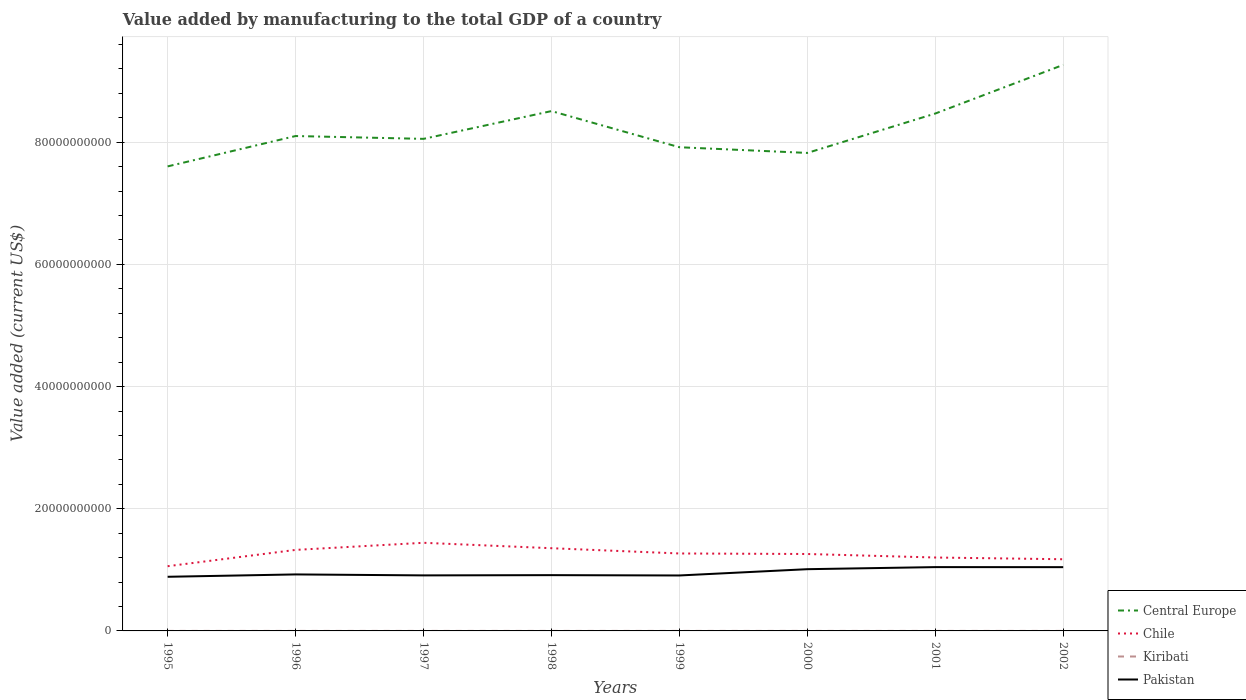Across all years, what is the maximum value added by manufacturing to the total GDP in Pakistan?
Provide a succinct answer. 8.86e+09. What is the total value added by manufacturing to the total GDP in Central Europe in the graph?
Your answer should be compact. 1.37e+09. What is the difference between the highest and the second highest value added by manufacturing to the total GDP in Kiribati?
Your answer should be compact. 7.70e+05. How many lines are there?
Offer a terse response. 4. How many years are there in the graph?
Ensure brevity in your answer.  8. What is the difference between two consecutive major ticks on the Y-axis?
Your answer should be compact. 2.00e+1. Does the graph contain any zero values?
Provide a succinct answer. No. What is the title of the graph?
Provide a succinct answer. Value added by manufacturing to the total GDP of a country. What is the label or title of the X-axis?
Keep it short and to the point. Years. What is the label or title of the Y-axis?
Ensure brevity in your answer.  Value added (current US$). What is the Value added (current US$) of Central Europe in 1995?
Offer a terse response. 7.60e+1. What is the Value added (current US$) in Chile in 1995?
Your answer should be very brief. 1.06e+1. What is the Value added (current US$) in Kiribati in 1995?
Provide a succinct answer. 3.37e+06. What is the Value added (current US$) in Pakistan in 1995?
Provide a succinct answer. 8.86e+09. What is the Value added (current US$) of Central Europe in 1996?
Keep it short and to the point. 8.10e+1. What is the Value added (current US$) in Chile in 1996?
Offer a terse response. 1.33e+1. What is the Value added (current US$) of Kiribati in 1996?
Your answer should be very brief. 3.55e+06. What is the Value added (current US$) in Pakistan in 1996?
Your answer should be very brief. 9.25e+09. What is the Value added (current US$) in Central Europe in 1997?
Ensure brevity in your answer.  8.06e+1. What is the Value added (current US$) of Chile in 1997?
Your answer should be compact. 1.44e+1. What is the Value added (current US$) in Kiribati in 1997?
Provide a short and direct response. 3.47e+06. What is the Value added (current US$) of Pakistan in 1997?
Your answer should be compact. 9.09e+09. What is the Value added (current US$) in Central Europe in 1998?
Your response must be concise. 8.51e+1. What is the Value added (current US$) in Chile in 1998?
Your answer should be compact. 1.35e+1. What is the Value added (current US$) of Kiribati in 1998?
Your answer should be very brief. 3.13e+06. What is the Value added (current US$) in Pakistan in 1998?
Offer a very short reply. 9.13e+09. What is the Value added (current US$) in Central Europe in 1999?
Provide a short and direct response. 7.92e+1. What is the Value added (current US$) in Chile in 1999?
Ensure brevity in your answer.  1.27e+1. What is the Value added (current US$) of Kiribati in 1999?
Your answer should be very brief. 3.52e+06. What is the Value added (current US$) in Pakistan in 1999?
Keep it short and to the point. 9.08e+09. What is the Value added (current US$) of Central Europe in 2000?
Offer a terse response. 7.82e+1. What is the Value added (current US$) in Chile in 2000?
Make the answer very short. 1.26e+1. What is the Value added (current US$) in Kiribati in 2000?
Provide a succinct answer. 2.98e+06. What is the Value added (current US$) of Pakistan in 2000?
Provide a succinct answer. 1.01e+1. What is the Value added (current US$) of Central Europe in 2001?
Offer a terse response. 8.47e+1. What is the Value added (current US$) of Chile in 2001?
Provide a short and direct response. 1.20e+1. What is the Value added (current US$) in Kiribati in 2001?
Your response must be concise. 2.78e+06. What is the Value added (current US$) of Pakistan in 2001?
Provide a succinct answer. 1.04e+1. What is the Value added (current US$) of Central Europe in 2002?
Offer a terse response. 9.27e+1. What is the Value added (current US$) of Chile in 2002?
Provide a succinct answer. 1.17e+1. What is the Value added (current US$) of Kiribati in 2002?
Offer a very short reply. 2.85e+06. What is the Value added (current US$) of Pakistan in 2002?
Offer a very short reply. 1.04e+1. Across all years, what is the maximum Value added (current US$) of Central Europe?
Offer a very short reply. 9.27e+1. Across all years, what is the maximum Value added (current US$) in Chile?
Your response must be concise. 1.44e+1. Across all years, what is the maximum Value added (current US$) of Kiribati?
Provide a succinct answer. 3.55e+06. Across all years, what is the maximum Value added (current US$) in Pakistan?
Keep it short and to the point. 1.04e+1. Across all years, what is the minimum Value added (current US$) of Central Europe?
Provide a short and direct response. 7.60e+1. Across all years, what is the minimum Value added (current US$) of Chile?
Ensure brevity in your answer.  1.06e+1. Across all years, what is the minimum Value added (current US$) in Kiribati?
Your response must be concise. 2.78e+06. Across all years, what is the minimum Value added (current US$) in Pakistan?
Provide a short and direct response. 8.86e+09. What is the total Value added (current US$) in Central Europe in the graph?
Ensure brevity in your answer.  6.57e+11. What is the total Value added (current US$) of Chile in the graph?
Make the answer very short. 1.01e+11. What is the total Value added (current US$) of Kiribati in the graph?
Ensure brevity in your answer.  2.57e+07. What is the total Value added (current US$) of Pakistan in the graph?
Give a very brief answer. 7.64e+1. What is the difference between the Value added (current US$) of Central Europe in 1995 and that in 1996?
Ensure brevity in your answer.  -4.97e+09. What is the difference between the Value added (current US$) in Chile in 1995 and that in 1996?
Offer a very short reply. -2.67e+09. What is the difference between the Value added (current US$) of Kiribati in 1995 and that in 1996?
Provide a succinct answer. -1.88e+05. What is the difference between the Value added (current US$) of Pakistan in 1995 and that in 1996?
Your answer should be compact. -3.86e+08. What is the difference between the Value added (current US$) of Central Europe in 1995 and that in 1997?
Keep it short and to the point. -4.51e+09. What is the difference between the Value added (current US$) in Chile in 1995 and that in 1997?
Provide a short and direct response. -3.83e+09. What is the difference between the Value added (current US$) in Kiribati in 1995 and that in 1997?
Provide a succinct answer. -1.05e+05. What is the difference between the Value added (current US$) of Pakistan in 1995 and that in 1997?
Your response must be concise. -2.27e+08. What is the difference between the Value added (current US$) of Central Europe in 1995 and that in 1998?
Provide a short and direct response. -9.05e+09. What is the difference between the Value added (current US$) of Chile in 1995 and that in 1998?
Your response must be concise. -2.95e+09. What is the difference between the Value added (current US$) of Kiribati in 1995 and that in 1998?
Ensure brevity in your answer.  2.32e+05. What is the difference between the Value added (current US$) in Pakistan in 1995 and that in 1998?
Offer a terse response. -2.68e+08. What is the difference between the Value added (current US$) in Central Europe in 1995 and that in 1999?
Make the answer very short. -3.14e+09. What is the difference between the Value added (current US$) of Chile in 1995 and that in 1999?
Make the answer very short. -2.08e+09. What is the difference between the Value added (current US$) of Kiribati in 1995 and that in 1999?
Your response must be concise. -1.54e+05. What is the difference between the Value added (current US$) in Pakistan in 1995 and that in 1999?
Make the answer very short. -2.13e+08. What is the difference between the Value added (current US$) of Central Europe in 1995 and that in 2000?
Your answer should be very brief. -2.21e+09. What is the difference between the Value added (current US$) of Chile in 1995 and that in 2000?
Keep it short and to the point. -2.00e+09. What is the difference between the Value added (current US$) in Kiribati in 1995 and that in 2000?
Make the answer very short. 3.87e+05. What is the difference between the Value added (current US$) in Pakistan in 1995 and that in 2000?
Give a very brief answer. -1.24e+09. What is the difference between the Value added (current US$) of Central Europe in 1995 and that in 2001?
Keep it short and to the point. -8.65e+09. What is the difference between the Value added (current US$) of Chile in 1995 and that in 2001?
Make the answer very short. -1.42e+09. What is the difference between the Value added (current US$) of Kiribati in 1995 and that in 2001?
Your response must be concise. 5.82e+05. What is the difference between the Value added (current US$) in Pakistan in 1995 and that in 2001?
Provide a short and direct response. -1.58e+09. What is the difference between the Value added (current US$) in Central Europe in 1995 and that in 2002?
Your response must be concise. -1.66e+1. What is the difference between the Value added (current US$) of Chile in 1995 and that in 2002?
Offer a terse response. -1.14e+09. What is the difference between the Value added (current US$) in Kiribati in 1995 and that in 2002?
Give a very brief answer. 5.20e+05. What is the difference between the Value added (current US$) of Pakistan in 1995 and that in 2002?
Your answer should be very brief. -1.58e+09. What is the difference between the Value added (current US$) of Central Europe in 1996 and that in 1997?
Your response must be concise. 4.64e+08. What is the difference between the Value added (current US$) in Chile in 1996 and that in 1997?
Your answer should be very brief. -1.16e+09. What is the difference between the Value added (current US$) in Kiribati in 1996 and that in 1997?
Ensure brevity in your answer.  8.27e+04. What is the difference between the Value added (current US$) in Pakistan in 1996 and that in 1997?
Offer a terse response. 1.59e+08. What is the difference between the Value added (current US$) in Central Europe in 1996 and that in 1998?
Your answer should be compact. -4.08e+09. What is the difference between the Value added (current US$) in Chile in 1996 and that in 1998?
Provide a short and direct response. -2.76e+08. What is the difference between the Value added (current US$) in Kiribati in 1996 and that in 1998?
Your answer should be compact. 4.20e+05. What is the difference between the Value added (current US$) of Pakistan in 1996 and that in 1998?
Your answer should be very brief. 1.18e+08. What is the difference between the Value added (current US$) of Central Europe in 1996 and that in 1999?
Provide a succinct answer. 1.83e+09. What is the difference between the Value added (current US$) of Chile in 1996 and that in 1999?
Keep it short and to the point. 5.85e+08. What is the difference between the Value added (current US$) of Kiribati in 1996 and that in 1999?
Offer a very short reply. 3.37e+04. What is the difference between the Value added (current US$) of Pakistan in 1996 and that in 1999?
Give a very brief answer. 1.73e+08. What is the difference between the Value added (current US$) of Central Europe in 1996 and that in 2000?
Provide a short and direct response. 2.77e+09. What is the difference between the Value added (current US$) in Chile in 1996 and that in 2000?
Keep it short and to the point. 6.71e+08. What is the difference between the Value added (current US$) in Kiribati in 1996 and that in 2000?
Ensure brevity in your answer.  5.76e+05. What is the difference between the Value added (current US$) of Pakistan in 1996 and that in 2000?
Offer a terse response. -8.55e+08. What is the difference between the Value added (current US$) in Central Europe in 1996 and that in 2001?
Provide a succinct answer. -3.68e+09. What is the difference between the Value added (current US$) in Chile in 1996 and that in 2001?
Give a very brief answer. 1.25e+09. What is the difference between the Value added (current US$) of Kiribati in 1996 and that in 2001?
Provide a short and direct response. 7.70e+05. What is the difference between the Value added (current US$) in Pakistan in 1996 and that in 2001?
Your answer should be compact. -1.20e+09. What is the difference between the Value added (current US$) of Central Europe in 1996 and that in 2002?
Your answer should be very brief. -1.16e+1. What is the difference between the Value added (current US$) in Chile in 1996 and that in 2002?
Your answer should be very brief. 1.53e+09. What is the difference between the Value added (current US$) of Kiribati in 1996 and that in 2002?
Offer a terse response. 7.08e+05. What is the difference between the Value added (current US$) of Pakistan in 1996 and that in 2002?
Make the answer very short. -1.19e+09. What is the difference between the Value added (current US$) in Central Europe in 1997 and that in 1998?
Provide a succinct answer. -4.55e+09. What is the difference between the Value added (current US$) of Chile in 1997 and that in 1998?
Your answer should be very brief. 8.87e+08. What is the difference between the Value added (current US$) of Kiribati in 1997 and that in 1998?
Offer a very short reply. 3.37e+05. What is the difference between the Value added (current US$) of Pakistan in 1997 and that in 1998?
Keep it short and to the point. -4.09e+07. What is the difference between the Value added (current US$) in Central Europe in 1997 and that in 1999?
Offer a terse response. 1.37e+09. What is the difference between the Value added (current US$) in Chile in 1997 and that in 1999?
Offer a terse response. 1.75e+09. What is the difference between the Value added (current US$) of Kiribati in 1997 and that in 1999?
Your answer should be very brief. -4.90e+04. What is the difference between the Value added (current US$) of Pakistan in 1997 and that in 1999?
Provide a succinct answer. 1.38e+07. What is the difference between the Value added (current US$) of Central Europe in 1997 and that in 2000?
Give a very brief answer. 2.30e+09. What is the difference between the Value added (current US$) in Chile in 1997 and that in 2000?
Give a very brief answer. 1.83e+09. What is the difference between the Value added (current US$) in Kiribati in 1997 and that in 2000?
Give a very brief answer. 4.93e+05. What is the difference between the Value added (current US$) of Pakistan in 1997 and that in 2000?
Offer a very short reply. -1.01e+09. What is the difference between the Value added (current US$) in Central Europe in 1997 and that in 2001?
Make the answer very short. -4.15e+09. What is the difference between the Value added (current US$) in Chile in 1997 and that in 2001?
Offer a terse response. 2.41e+09. What is the difference between the Value added (current US$) of Kiribati in 1997 and that in 2001?
Make the answer very short. 6.88e+05. What is the difference between the Value added (current US$) of Pakistan in 1997 and that in 2001?
Ensure brevity in your answer.  -1.35e+09. What is the difference between the Value added (current US$) in Central Europe in 1997 and that in 2002?
Provide a short and direct response. -1.21e+1. What is the difference between the Value added (current US$) of Chile in 1997 and that in 2002?
Provide a short and direct response. 2.69e+09. What is the difference between the Value added (current US$) of Kiribati in 1997 and that in 2002?
Offer a terse response. 6.25e+05. What is the difference between the Value added (current US$) of Pakistan in 1997 and that in 2002?
Ensure brevity in your answer.  -1.35e+09. What is the difference between the Value added (current US$) of Central Europe in 1998 and that in 1999?
Make the answer very short. 5.92e+09. What is the difference between the Value added (current US$) of Chile in 1998 and that in 1999?
Your answer should be very brief. 8.62e+08. What is the difference between the Value added (current US$) in Kiribati in 1998 and that in 1999?
Offer a very short reply. -3.86e+05. What is the difference between the Value added (current US$) of Pakistan in 1998 and that in 1999?
Ensure brevity in your answer.  5.46e+07. What is the difference between the Value added (current US$) in Central Europe in 1998 and that in 2000?
Make the answer very short. 6.85e+09. What is the difference between the Value added (current US$) in Chile in 1998 and that in 2000?
Offer a terse response. 9.47e+08. What is the difference between the Value added (current US$) in Kiribati in 1998 and that in 2000?
Offer a very short reply. 1.56e+05. What is the difference between the Value added (current US$) in Pakistan in 1998 and that in 2000?
Provide a succinct answer. -9.73e+08. What is the difference between the Value added (current US$) in Central Europe in 1998 and that in 2001?
Your response must be concise. 4.01e+08. What is the difference between the Value added (current US$) of Chile in 1998 and that in 2001?
Your answer should be very brief. 1.52e+09. What is the difference between the Value added (current US$) in Kiribati in 1998 and that in 2001?
Keep it short and to the point. 3.51e+05. What is the difference between the Value added (current US$) in Pakistan in 1998 and that in 2001?
Offer a terse response. -1.31e+09. What is the difference between the Value added (current US$) in Central Europe in 1998 and that in 2002?
Your answer should be very brief. -7.56e+09. What is the difference between the Value added (current US$) of Chile in 1998 and that in 2002?
Keep it short and to the point. 1.81e+09. What is the difference between the Value added (current US$) of Kiribati in 1998 and that in 2002?
Provide a short and direct response. 2.88e+05. What is the difference between the Value added (current US$) of Pakistan in 1998 and that in 2002?
Offer a very short reply. -1.31e+09. What is the difference between the Value added (current US$) of Central Europe in 1999 and that in 2000?
Make the answer very short. 9.32e+08. What is the difference between the Value added (current US$) in Chile in 1999 and that in 2000?
Ensure brevity in your answer.  8.55e+07. What is the difference between the Value added (current US$) of Kiribati in 1999 and that in 2000?
Offer a terse response. 5.42e+05. What is the difference between the Value added (current US$) of Pakistan in 1999 and that in 2000?
Make the answer very short. -1.03e+09. What is the difference between the Value added (current US$) of Central Europe in 1999 and that in 2001?
Keep it short and to the point. -5.52e+09. What is the difference between the Value added (current US$) of Chile in 1999 and that in 2001?
Provide a short and direct response. 6.61e+08. What is the difference between the Value added (current US$) of Kiribati in 1999 and that in 2001?
Your response must be concise. 7.37e+05. What is the difference between the Value added (current US$) in Pakistan in 1999 and that in 2001?
Offer a very short reply. -1.37e+09. What is the difference between the Value added (current US$) of Central Europe in 1999 and that in 2002?
Your response must be concise. -1.35e+1. What is the difference between the Value added (current US$) of Chile in 1999 and that in 2002?
Give a very brief answer. 9.45e+08. What is the difference between the Value added (current US$) in Kiribati in 1999 and that in 2002?
Keep it short and to the point. 6.74e+05. What is the difference between the Value added (current US$) in Pakistan in 1999 and that in 2002?
Make the answer very short. -1.36e+09. What is the difference between the Value added (current US$) of Central Europe in 2000 and that in 2001?
Provide a succinct answer. -6.45e+09. What is the difference between the Value added (current US$) of Chile in 2000 and that in 2001?
Your answer should be compact. 5.75e+08. What is the difference between the Value added (current US$) in Kiribati in 2000 and that in 2001?
Provide a succinct answer. 1.95e+05. What is the difference between the Value added (current US$) in Pakistan in 2000 and that in 2001?
Keep it short and to the point. -3.41e+08. What is the difference between the Value added (current US$) of Central Europe in 2000 and that in 2002?
Your answer should be very brief. -1.44e+1. What is the difference between the Value added (current US$) in Chile in 2000 and that in 2002?
Offer a very short reply. 8.59e+08. What is the difference between the Value added (current US$) in Kiribati in 2000 and that in 2002?
Ensure brevity in your answer.  1.32e+05. What is the difference between the Value added (current US$) in Pakistan in 2000 and that in 2002?
Make the answer very short. -3.34e+08. What is the difference between the Value added (current US$) in Central Europe in 2001 and that in 2002?
Provide a succinct answer. -7.97e+09. What is the difference between the Value added (current US$) in Chile in 2001 and that in 2002?
Your answer should be very brief. 2.84e+08. What is the difference between the Value added (current US$) in Kiribati in 2001 and that in 2002?
Provide a short and direct response. -6.24e+04. What is the difference between the Value added (current US$) in Pakistan in 2001 and that in 2002?
Ensure brevity in your answer.  6.15e+06. What is the difference between the Value added (current US$) of Central Europe in 1995 and the Value added (current US$) of Chile in 1996?
Provide a succinct answer. 6.28e+1. What is the difference between the Value added (current US$) in Central Europe in 1995 and the Value added (current US$) in Kiribati in 1996?
Your answer should be compact. 7.60e+1. What is the difference between the Value added (current US$) in Central Europe in 1995 and the Value added (current US$) in Pakistan in 1996?
Ensure brevity in your answer.  6.68e+1. What is the difference between the Value added (current US$) of Chile in 1995 and the Value added (current US$) of Kiribati in 1996?
Give a very brief answer. 1.06e+1. What is the difference between the Value added (current US$) in Chile in 1995 and the Value added (current US$) in Pakistan in 1996?
Provide a short and direct response. 1.34e+09. What is the difference between the Value added (current US$) in Kiribati in 1995 and the Value added (current US$) in Pakistan in 1996?
Offer a terse response. -9.25e+09. What is the difference between the Value added (current US$) in Central Europe in 1995 and the Value added (current US$) in Chile in 1997?
Provide a succinct answer. 6.16e+1. What is the difference between the Value added (current US$) of Central Europe in 1995 and the Value added (current US$) of Kiribati in 1997?
Make the answer very short. 7.60e+1. What is the difference between the Value added (current US$) in Central Europe in 1995 and the Value added (current US$) in Pakistan in 1997?
Offer a terse response. 6.70e+1. What is the difference between the Value added (current US$) of Chile in 1995 and the Value added (current US$) of Kiribati in 1997?
Provide a succinct answer. 1.06e+1. What is the difference between the Value added (current US$) of Chile in 1995 and the Value added (current US$) of Pakistan in 1997?
Give a very brief answer. 1.50e+09. What is the difference between the Value added (current US$) in Kiribati in 1995 and the Value added (current US$) in Pakistan in 1997?
Your response must be concise. -9.09e+09. What is the difference between the Value added (current US$) in Central Europe in 1995 and the Value added (current US$) in Chile in 1998?
Your answer should be compact. 6.25e+1. What is the difference between the Value added (current US$) in Central Europe in 1995 and the Value added (current US$) in Kiribati in 1998?
Your answer should be very brief. 7.60e+1. What is the difference between the Value added (current US$) in Central Europe in 1995 and the Value added (current US$) in Pakistan in 1998?
Make the answer very short. 6.69e+1. What is the difference between the Value added (current US$) of Chile in 1995 and the Value added (current US$) of Kiribati in 1998?
Give a very brief answer. 1.06e+1. What is the difference between the Value added (current US$) of Chile in 1995 and the Value added (current US$) of Pakistan in 1998?
Ensure brevity in your answer.  1.46e+09. What is the difference between the Value added (current US$) of Kiribati in 1995 and the Value added (current US$) of Pakistan in 1998?
Keep it short and to the point. -9.13e+09. What is the difference between the Value added (current US$) in Central Europe in 1995 and the Value added (current US$) in Chile in 1999?
Provide a succinct answer. 6.34e+1. What is the difference between the Value added (current US$) in Central Europe in 1995 and the Value added (current US$) in Kiribati in 1999?
Make the answer very short. 7.60e+1. What is the difference between the Value added (current US$) in Central Europe in 1995 and the Value added (current US$) in Pakistan in 1999?
Make the answer very short. 6.70e+1. What is the difference between the Value added (current US$) in Chile in 1995 and the Value added (current US$) in Kiribati in 1999?
Give a very brief answer. 1.06e+1. What is the difference between the Value added (current US$) of Chile in 1995 and the Value added (current US$) of Pakistan in 1999?
Make the answer very short. 1.52e+09. What is the difference between the Value added (current US$) in Kiribati in 1995 and the Value added (current US$) in Pakistan in 1999?
Offer a terse response. -9.07e+09. What is the difference between the Value added (current US$) of Central Europe in 1995 and the Value added (current US$) of Chile in 2000?
Offer a terse response. 6.35e+1. What is the difference between the Value added (current US$) of Central Europe in 1995 and the Value added (current US$) of Kiribati in 2000?
Ensure brevity in your answer.  7.60e+1. What is the difference between the Value added (current US$) in Central Europe in 1995 and the Value added (current US$) in Pakistan in 2000?
Your answer should be compact. 6.59e+1. What is the difference between the Value added (current US$) of Chile in 1995 and the Value added (current US$) of Kiribati in 2000?
Your answer should be very brief. 1.06e+1. What is the difference between the Value added (current US$) of Chile in 1995 and the Value added (current US$) of Pakistan in 2000?
Keep it short and to the point. 4.89e+08. What is the difference between the Value added (current US$) of Kiribati in 1995 and the Value added (current US$) of Pakistan in 2000?
Provide a short and direct response. -1.01e+1. What is the difference between the Value added (current US$) of Central Europe in 1995 and the Value added (current US$) of Chile in 2001?
Give a very brief answer. 6.40e+1. What is the difference between the Value added (current US$) in Central Europe in 1995 and the Value added (current US$) in Kiribati in 2001?
Your response must be concise. 7.60e+1. What is the difference between the Value added (current US$) in Central Europe in 1995 and the Value added (current US$) in Pakistan in 2001?
Make the answer very short. 6.56e+1. What is the difference between the Value added (current US$) in Chile in 1995 and the Value added (current US$) in Kiribati in 2001?
Provide a succinct answer. 1.06e+1. What is the difference between the Value added (current US$) of Chile in 1995 and the Value added (current US$) of Pakistan in 2001?
Provide a short and direct response. 1.48e+08. What is the difference between the Value added (current US$) of Kiribati in 1995 and the Value added (current US$) of Pakistan in 2001?
Provide a short and direct response. -1.04e+1. What is the difference between the Value added (current US$) of Central Europe in 1995 and the Value added (current US$) of Chile in 2002?
Provide a succinct answer. 6.43e+1. What is the difference between the Value added (current US$) of Central Europe in 1995 and the Value added (current US$) of Kiribati in 2002?
Offer a terse response. 7.60e+1. What is the difference between the Value added (current US$) of Central Europe in 1995 and the Value added (current US$) of Pakistan in 2002?
Give a very brief answer. 6.56e+1. What is the difference between the Value added (current US$) in Chile in 1995 and the Value added (current US$) in Kiribati in 2002?
Ensure brevity in your answer.  1.06e+1. What is the difference between the Value added (current US$) of Chile in 1995 and the Value added (current US$) of Pakistan in 2002?
Provide a succinct answer. 1.54e+08. What is the difference between the Value added (current US$) in Kiribati in 1995 and the Value added (current US$) in Pakistan in 2002?
Ensure brevity in your answer.  -1.04e+1. What is the difference between the Value added (current US$) in Central Europe in 1996 and the Value added (current US$) in Chile in 1997?
Keep it short and to the point. 6.66e+1. What is the difference between the Value added (current US$) of Central Europe in 1996 and the Value added (current US$) of Kiribati in 1997?
Offer a very short reply. 8.10e+1. What is the difference between the Value added (current US$) of Central Europe in 1996 and the Value added (current US$) of Pakistan in 1997?
Offer a very short reply. 7.19e+1. What is the difference between the Value added (current US$) in Chile in 1996 and the Value added (current US$) in Kiribati in 1997?
Provide a succinct answer. 1.33e+1. What is the difference between the Value added (current US$) in Chile in 1996 and the Value added (current US$) in Pakistan in 1997?
Your response must be concise. 4.17e+09. What is the difference between the Value added (current US$) of Kiribati in 1996 and the Value added (current US$) of Pakistan in 1997?
Your answer should be very brief. -9.09e+09. What is the difference between the Value added (current US$) of Central Europe in 1996 and the Value added (current US$) of Chile in 1998?
Your answer should be compact. 6.75e+1. What is the difference between the Value added (current US$) in Central Europe in 1996 and the Value added (current US$) in Kiribati in 1998?
Keep it short and to the point. 8.10e+1. What is the difference between the Value added (current US$) in Central Europe in 1996 and the Value added (current US$) in Pakistan in 1998?
Give a very brief answer. 7.19e+1. What is the difference between the Value added (current US$) of Chile in 1996 and the Value added (current US$) of Kiribati in 1998?
Keep it short and to the point. 1.33e+1. What is the difference between the Value added (current US$) of Chile in 1996 and the Value added (current US$) of Pakistan in 1998?
Your answer should be compact. 4.13e+09. What is the difference between the Value added (current US$) in Kiribati in 1996 and the Value added (current US$) in Pakistan in 1998?
Provide a short and direct response. -9.13e+09. What is the difference between the Value added (current US$) of Central Europe in 1996 and the Value added (current US$) of Chile in 1999?
Offer a very short reply. 6.83e+1. What is the difference between the Value added (current US$) of Central Europe in 1996 and the Value added (current US$) of Kiribati in 1999?
Offer a very short reply. 8.10e+1. What is the difference between the Value added (current US$) of Central Europe in 1996 and the Value added (current US$) of Pakistan in 1999?
Make the answer very short. 7.19e+1. What is the difference between the Value added (current US$) in Chile in 1996 and the Value added (current US$) in Kiribati in 1999?
Offer a terse response. 1.33e+1. What is the difference between the Value added (current US$) in Chile in 1996 and the Value added (current US$) in Pakistan in 1999?
Offer a very short reply. 4.19e+09. What is the difference between the Value added (current US$) in Kiribati in 1996 and the Value added (current US$) in Pakistan in 1999?
Keep it short and to the point. -9.07e+09. What is the difference between the Value added (current US$) in Central Europe in 1996 and the Value added (current US$) in Chile in 2000?
Your response must be concise. 6.84e+1. What is the difference between the Value added (current US$) of Central Europe in 1996 and the Value added (current US$) of Kiribati in 2000?
Make the answer very short. 8.10e+1. What is the difference between the Value added (current US$) of Central Europe in 1996 and the Value added (current US$) of Pakistan in 2000?
Ensure brevity in your answer.  7.09e+1. What is the difference between the Value added (current US$) of Chile in 1996 and the Value added (current US$) of Kiribati in 2000?
Offer a terse response. 1.33e+1. What is the difference between the Value added (current US$) in Chile in 1996 and the Value added (current US$) in Pakistan in 2000?
Your response must be concise. 3.16e+09. What is the difference between the Value added (current US$) of Kiribati in 1996 and the Value added (current US$) of Pakistan in 2000?
Offer a terse response. -1.01e+1. What is the difference between the Value added (current US$) of Central Europe in 1996 and the Value added (current US$) of Chile in 2001?
Make the answer very short. 6.90e+1. What is the difference between the Value added (current US$) of Central Europe in 1996 and the Value added (current US$) of Kiribati in 2001?
Your response must be concise. 8.10e+1. What is the difference between the Value added (current US$) of Central Europe in 1996 and the Value added (current US$) of Pakistan in 2001?
Give a very brief answer. 7.06e+1. What is the difference between the Value added (current US$) in Chile in 1996 and the Value added (current US$) in Kiribati in 2001?
Ensure brevity in your answer.  1.33e+1. What is the difference between the Value added (current US$) in Chile in 1996 and the Value added (current US$) in Pakistan in 2001?
Provide a short and direct response. 2.82e+09. What is the difference between the Value added (current US$) in Kiribati in 1996 and the Value added (current US$) in Pakistan in 2001?
Make the answer very short. -1.04e+1. What is the difference between the Value added (current US$) in Central Europe in 1996 and the Value added (current US$) in Chile in 2002?
Make the answer very short. 6.93e+1. What is the difference between the Value added (current US$) in Central Europe in 1996 and the Value added (current US$) in Kiribati in 2002?
Your answer should be compact. 8.10e+1. What is the difference between the Value added (current US$) in Central Europe in 1996 and the Value added (current US$) in Pakistan in 2002?
Offer a very short reply. 7.06e+1. What is the difference between the Value added (current US$) in Chile in 1996 and the Value added (current US$) in Kiribati in 2002?
Make the answer very short. 1.33e+1. What is the difference between the Value added (current US$) in Chile in 1996 and the Value added (current US$) in Pakistan in 2002?
Give a very brief answer. 2.82e+09. What is the difference between the Value added (current US$) of Kiribati in 1996 and the Value added (current US$) of Pakistan in 2002?
Provide a short and direct response. -1.04e+1. What is the difference between the Value added (current US$) in Central Europe in 1997 and the Value added (current US$) in Chile in 1998?
Make the answer very short. 6.70e+1. What is the difference between the Value added (current US$) in Central Europe in 1997 and the Value added (current US$) in Kiribati in 1998?
Your response must be concise. 8.05e+1. What is the difference between the Value added (current US$) in Central Europe in 1997 and the Value added (current US$) in Pakistan in 1998?
Provide a short and direct response. 7.14e+1. What is the difference between the Value added (current US$) of Chile in 1997 and the Value added (current US$) of Kiribati in 1998?
Provide a succinct answer. 1.44e+1. What is the difference between the Value added (current US$) in Chile in 1997 and the Value added (current US$) in Pakistan in 1998?
Your response must be concise. 5.30e+09. What is the difference between the Value added (current US$) in Kiribati in 1997 and the Value added (current US$) in Pakistan in 1998?
Your response must be concise. -9.13e+09. What is the difference between the Value added (current US$) in Central Europe in 1997 and the Value added (current US$) in Chile in 1999?
Provide a succinct answer. 6.79e+1. What is the difference between the Value added (current US$) of Central Europe in 1997 and the Value added (current US$) of Kiribati in 1999?
Ensure brevity in your answer.  8.05e+1. What is the difference between the Value added (current US$) of Central Europe in 1997 and the Value added (current US$) of Pakistan in 1999?
Ensure brevity in your answer.  7.15e+1. What is the difference between the Value added (current US$) of Chile in 1997 and the Value added (current US$) of Kiribati in 1999?
Your answer should be very brief. 1.44e+1. What is the difference between the Value added (current US$) of Chile in 1997 and the Value added (current US$) of Pakistan in 1999?
Provide a short and direct response. 5.35e+09. What is the difference between the Value added (current US$) in Kiribati in 1997 and the Value added (current US$) in Pakistan in 1999?
Offer a terse response. -9.07e+09. What is the difference between the Value added (current US$) of Central Europe in 1997 and the Value added (current US$) of Chile in 2000?
Keep it short and to the point. 6.80e+1. What is the difference between the Value added (current US$) in Central Europe in 1997 and the Value added (current US$) in Kiribati in 2000?
Your answer should be very brief. 8.05e+1. What is the difference between the Value added (current US$) of Central Europe in 1997 and the Value added (current US$) of Pakistan in 2000?
Give a very brief answer. 7.04e+1. What is the difference between the Value added (current US$) in Chile in 1997 and the Value added (current US$) in Kiribati in 2000?
Provide a succinct answer. 1.44e+1. What is the difference between the Value added (current US$) of Chile in 1997 and the Value added (current US$) of Pakistan in 2000?
Ensure brevity in your answer.  4.32e+09. What is the difference between the Value added (current US$) in Kiribati in 1997 and the Value added (current US$) in Pakistan in 2000?
Make the answer very short. -1.01e+1. What is the difference between the Value added (current US$) of Central Europe in 1997 and the Value added (current US$) of Chile in 2001?
Make the answer very short. 6.85e+1. What is the difference between the Value added (current US$) of Central Europe in 1997 and the Value added (current US$) of Kiribati in 2001?
Your response must be concise. 8.05e+1. What is the difference between the Value added (current US$) in Central Europe in 1997 and the Value added (current US$) in Pakistan in 2001?
Keep it short and to the point. 7.01e+1. What is the difference between the Value added (current US$) of Chile in 1997 and the Value added (current US$) of Kiribati in 2001?
Offer a very short reply. 1.44e+1. What is the difference between the Value added (current US$) in Chile in 1997 and the Value added (current US$) in Pakistan in 2001?
Give a very brief answer. 3.98e+09. What is the difference between the Value added (current US$) of Kiribati in 1997 and the Value added (current US$) of Pakistan in 2001?
Your answer should be compact. -1.04e+1. What is the difference between the Value added (current US$) in Central Europe in 1997 and the Value added (current US$) in Chile in 2002?
Ensure brevity in your answer.  6.88e+1. What is the difference between the Value added (current US$) in Central Europe in 1997 and the Value added (current US$) in Kiribati in 2002?
Your answer should be very brief. 8.05e+1. What is the difference between the Value added (current US$) in Central Europe in 1997 and the Value added (current US$) in Pakistan in 2002?
Ensure brevity in your answer.  7.01e+1. What is the difference between the Value added (current US$) of Chile in 1997 and the Value added (current US$) of Kiribati in 2002?
Make the answer very short. 1.44e+1. What is the difference between the Value added (current US$) in Chile in 1997 and the Value added (current US$) in Pakistan in 2002?
Your answer should be very brief. 3.99e+09. What is the difference between the Value added (current US$) of Kiribati in 1997 and the Value added (current US$) of Pakistan in 2002?
Offer a very short reply. -1.04e+1. What is the difference between the Value added (current US$) of Central Europe in 1998 and the Value added (current US$) of Chile in 1999?
Keep it short and to the point. 7.24e+1. What is the difference between the Value added (current US$) in Central Europe in 1998 and the Value added (current US$) in Kiribati in 1999?
Your response must be concise. 8.51e+1. What is the difference between the Value added (current US$) in Central Europe in 1998 and the Value added (current US$) in Pakistan in 1999?
Provide a succinct answer. 7.60e+1. What is the difference between the Value added (current US$) in Chile in 1998 and the Value added (current US$) in Kiribati in 1999?
Keep it short and to the point. 1.35e+1. What is the difference between the Value added (current US$) in Chile in 1998 and the Value added (current US$) in Pakistan in 1999?
Provide a short and direct response. 4.46e+09. What is the difference between the Value added (current US$) in Kiribati in 1998 and the Value added (current US$) in Pakistan in 1999?
Offer a very short reply. -9.07e+09. What is the difference between the Value added (current US$) of Central Europe in 1998 and the Value added (current US$) of Chile in 2000?
Make the answer very short. 7.25e+1. What is the difference between the Value added (current US$) of Central Europe in 1998 and the Value added (current US$) of Kiribati in 2000?
Offer a very short reply. 8.51e+1. What is the difference between the Value added (current US$) in Central Europe in 1998 and the Value added (current US$) in Pakistan in 2000?
Give a very brief answer. 7.50e+1. What is the difference between the Value added (current US$) in Chile in 1998 and the Value added (current US$) in Kiribati in 2000?
Your answer should be compact. 1.35e+1. What is the difference between the Value added (current US$) of Chile in 1998 and the Value added (current US$) of Pakistan in 2000?
Your answer should be very brief. 3.44e+09. What is the difference between the Value added (current US$) of Kiribati in 1998 and the Value added (current US$) of Pakistan in 2000?
Ensure brevity in your answer.  -1.01e+1. What is the difference between the Value added (current US$) in Central Europe in 1998 and the Value added (current US$) in Chile in 2001?
Provide a succinct answer. 7.31e+1. What is the difference between the Value added (current US$) of Central Europe in 1998 and the Value added (current US$) of Kiribati in 2001?
Offer a terse response. 8.51e+1. What is the difference between the Value added (current US$) of Central Europe in 1998 and the Value added (current US$) of Pakistan in 2001?
Give a very brief answer. 7.47e+1. What is the difference between the Value added (current US$) in Chile in 1998 and the Value added (current US$) in Kiribati in 2001?
Make the answer very short. 1.35e+1. What is the difference between the Value added (current US$) in Chile in 1998 and the Value added (current US$) in Pakistan in 2001?
Provide a succinct answer. 3.09e+09. What is the difference between the Value added (current US$) of Kiribati in 1998 and the Value added (current US$) of Pakistan in 2001?
Keep it short and to the point. -1.04e+1. What is the difference between the Value added (current US$) in Central Europe in 1998 and the Value added (current US$) in Chile in 2002?
Keep it short and to the point. 7.34e+1. What is the difference between the Value added (current US$) of Central Europe in 1998 and the Value added (current US$) of Kiribati in 2002?
Your answer should be very brief. 8.51e+1. What is the difference between the Value added (current US$) in Central Europe in 1998 and the Value added (current US$) in Pakistan in 2002?
Ensure brevity in your answer.  7.47e+1. What is the difference between the Value added (current US$) in Chile in 1998 and the Value added (current US$) in Kiribati in 2002?
Your answer should be very brief. 1.35e+1. What is the difference between the Value added (current US$) of Chile in 1998 and the Value added (current US$) of Pakistan in 2002?
Keep it short and to the point. 3.10e+09. What is the difference between the Value added (current US$) of Kiribati in 1998 and the Value added (current US$) of Pakistan in 2002?
Your answer should be compact. -1.04e+1. What is the difference between the Value added (current US$) in Central Europe in 1999 and the Value added (current US$) in Chile in 2000?
Provide a succinct answer. 6.66e+1. What is the difference between the Value added (current US$) in Central Europe in 1999 and the Value added (current US$) in Kiribati in 2000?
Your answer should be very brief. 7.92e+1. What is the difference between the Value added (current US$) of Central Europe in 1999 and the Value added (current US$) of Pakistan in 2000?
Give a very brief answer. 6.91e+1. What is the difference between the Value added (current US$) in Chile in 1999 and the Value added (current US$) in Kiribati in 2000?
Offer a terse response. 1.27e+1. What is the difference between the Value added (current US$) in Chile in 1999 and the Value added (current US$) in Pakistan in 2000?
Offer a terse response. 2.57e+09. What is the difference between the Value added (current US$) of Kiribati in 1999 and the Value added (current US$) of Pakistan in 2000?
Offer a terse response. -1.01e+1. What is the difference between the Value added (current US$) in Central Europe in 1999 and the Value added (current US$) in Chile in 2001?
Your answer should be compact. 6.72e+1. What is the difference between the Value added (current US$) of Central Europe in 1999 and the Value added (current US$) of Kiribati in 2001?
Your response must be concise. 7.92e+1. What is the difference between the Value added (current US$) of Central Europe in 1999 and the Value added (current US$) of Pakistan in 2001?
Your response must be concise. 6.87e+1. What is the difference between the Value added (current US$) of Chile in 1999 and the Value added (current US$) of Kiribati in 2001?
Provide a short and direct response. 1.27e+1. What is the difference between the Value added (current US$) of Chile in 1999 and the Value added (current US$) of Pakistan in 2001?
Make the answer very short. 2.23e+09. What is the difference between the Value added (current US$) in Kiribati in 1999 and the Value added (current US$) in Pakistan in 2001?
Ensure brevity in your answer.  -1.04e+1. What is the difference between the Value added (current US$) of Central Europe in 1999 and the Value added (current US$) of Chile in 2002?
Your answer should be compact. 6.74e+1. What is the difference between the Value added (current US$) in Central Europe in 1999 and the Value added (current US$) in Kiribati in 2002?
Offer a terse response. 7.92e+1. What is the difference between the Value added (current US$) in Central Europe in 1999 and the Value added (current US$) in Pakistan in 2002?
Your response must be concise. 6.87e+1. What is the difference between the Value added (current US$) in Chile in 1999 and the Value added (current US$) in Kiribati in 2002?
Ensure brevity in your answer.  1.27e+1. What is the difference between the Value added (current US$) of Chile in 1999 and the Value added (current US$) of Pakistan in 2002?
Your response must be concise. 2.24e+09. What is the difference between the Value added (current US$) in Kiribati in 1999 and the Value added (current US$) in Pakistan in 2002?
Offer a terse response. -1.04e+1. What is the difference between the Value added (current US$) in Central Europe in 2000 and the Value added (current US$) in Chile in 2001?
Give a very brief answer. 6.62e+1. What is the difference between the Value added (current US$) in Central Europe in 2000 and the Value added (current US$) in Kiribati in 2001?
Give a very brief answer. 7.82e+1. What is the difference between the Value added (current US$) in Central Europe in 2000 and the Value added (current US$) in Pakistan in 2001?
Provide a short and direct response. 6.78e+1. What is the difference between the Value added (current US$) in Chile in 2000 and the Value added (current US$) in Kiribati in 2001?
Ensure brevity in your answer.  1.26e+1. What is the difference between the Value added (current US$) in Chile in 2000 and the Value added (current US$) in Pakistan in 2001?
Your answer should be compact. 2.15e+09. What is the difference between the Value added (current US$) in Kiribati in 2000 and the Value added (current US$) in Pakistan in 2001?
Ensure brevity in your answer.  -1.04e+1. What is the difference between the Value added (current US$) of Central Europe in 2000 and the Value added (current US$) of Chile in 2002?
Offer a terse response. 6.65e+1. What is the difference between the Value added (current US$) of Central Europe in 2000 and the Value added (current US$) of Kiribati in 2002?
Keep it short and to the point. 7.82e+1. What is the difference between the Value added (current US$) in Central Europe in 2000 and the Value added (current US$) in Pakistan in 2002?
Ensure brevity in your answer.  6.78e+1. What is the difference between the Value added (current US$) of Chile in 2000 and the Value added (current US$) of Kiribati in 2002?
Provide a short and direct response. 1.26e+1. What is the difference between the Value added (current US$) of Chile in 2000 and the Value added (current US$) of Pakistan in 2002?
Offer a very short reply. 2.15e+09. What is the difference between the Value added (current US$) of Kiribati in 2000 and the Value added (current US$) of Pakistan in 2002?
Your response must be concise. -1.04e+1. What is the difference between the Value added (current US$) of Central Europe in 2001 and the Value added (current US$) of Chile in 2002?
Your answer should be compact. 7.30e+1. What is the difference between the Value added (current US$) in Central Europe in 2001 and the Value added (current US$) in Kiribati in 2002?
Your response must be concise. 8.47e+1. What is the difference between the Value added (current US$) in Central Europe in 2001 and the Value added (current US$) in Pakistan in 2002?
Offer a very short reply. 7.43e+1. What is the difference between the Value added (current US$) in Chile in 2001 and the Value added (current US$) in Kiribati in 2002?
Keep it short and to the point. 1.20e+1. What is the difference between the Value added (current US$) of Chile in 2001 and the Value added (current US$) of Pakistan in 2002?
Provide a succinct answer. 1.58e+09. What is the difference between the Value added (current US$) of Kiribati in 2001 and the Value added (current US$) of Pakistan in 2002?
Your answer should be compact. -1.04e+1. What is the average Value added (current US$) in Central Europe per year?
Provide a succinct answer. 8.22e+1. What is the average Value added (current US$) in Chile per year?
Your answer should be compact. 1.26e+1. What is the average Value added (current US$) of Kiribati per year?
Offer a very short reply. 3.21e+06. What is the average Value added (current US$) in Pakistan per year?
Your answer should be very brief. 9.55e+09. In the year 1995, what is the difference between the Value added (current US$) of Central Europe and Value added (current US$) of Chile?
Provide a succinct answer. 6.54e+1. In the year 1995, what is the difference between the Value added (current US$) in Central Europe and Value added (current US$) in Kiribati?
Offer a very short reply. 7.60e+1. In the year 1995, what is the difference between the Value added (current US$) of Central Europe and Value added (current US$) of Pakistan?
Your answer should be compact. 6.72e+1. In the year 1995, what is the difference between the Value added (current US$) in Chile and Value added (current US$) in Kiribati?
Give a very brief answer. 1.06e+1. In the year 1995, what is the difference between the Value added (current US$) in Chile and Value added (current US$) in Pakistan?
Your answer should be compact. 1.73e+09. In the year 1995, what is the difference between the Value added (current US$) of Kiribati and Value added (current US$) of Pakistan?
Provide a short and direct response. -8.86e+09. In the year 1996, what is the difference between the Value added (current US$) of Central Europe and Value added (current US$) of Chile?
Give a very brief answer. 6.78e+1. In the year 1996, what is the difference between the Value added (current US$) of Central Europe and Value added (current US$) of Kiribati?
Your answer should be compact. 8.10e+1. In the year 1996, what is the difference between the Value added (current US$) of Central Europe and Value added (current US$) of Pakistan?
Provide a succinct answer. 7.18e+1. In the year 1996, what is the difference between the Value added (current US$) of Chile and Value added (current US$) of Kiribati?
Offer a very short reply. 1.33e+1. In the year 1996, what is the difference between the Value added (current US$) of Chile and Value added (current US$) of Pakistan?
Provide a succinct answer. 4.01e+09. In the year 1996, what is the difference between the Value added (current US$) of Kiribati and Value added (current US$) of Pakistan?
Your answer should be compact. -9.25e+09. In the year 1997, what is the difference between the Value added (current US$) of Central Europe and Value added (current US$) of Chile?
Offer a very short reply. 6.61e+1. In the year 1997, what is the difference between the Value added (current US$) in Central Europe and Value added (current US$) in Kiribati?
Keep it short and to the point. 8.05e+1. In the year 1997, what is the difference between the Value added (current US$) of Central Europe and Value added (current US$) of Pakistan?
Make the answer very short. 7.15e+1. In the year 1997, what is the difference between the Value added (current US$) in Chile and Value added (current US$) in Kiribati?
Keep it short and to the point. 1.44e+1. In the year 1997, what is the difference between the Value added (current US$) of Chile and Value added (current US$) of Pakistan?
Provide a succinct answer. 5.34e+09. In the year 1997, what is the difference between the Value added (current US$) of Kiribati and Value added (current US$) of Pakistan?
Your response must be concise. -9.09e+09. In the year 1998, what is the difference between the Value added (current US$) of Central Europe and Value added (current US$) of Chile?
Make the answer very short. 7.16e+1. In the year 1998, what is the difference between the Value added (current US$) of Central Europe and Value added (current US$) of Kiribati?
Keep it short and to the point. 8.51e+1. In the year 1998, what is the difference between the Value added (current US$) of Central Europe and Value added (current US$) of Pakistan?
Your answer should be compact. 7.60e+1. In the year 1998, what is the difference between the Value added (current US$) in Chile and Value added (current US$) in Kiribati?
Ensure brevity in your answer.  1.35e+1. In the year 1998, what is the difference between the Value added (current US$) of Chile and Value added (current US$) of Pakistan?
Offer a very short reply. 4.41e+09. In the year 1998, what is the difference between the Value added (current US$) in Kiribati and Value added (current US$) in Pakistan?
Provide a succinct answer. -9.13e+09. In the year 1999, what is the difference between the Value added (current US$) in Central Europe and Value added (current US$) in Chile?
Offer a terse response. 6.65e+1. In the year 1999, what is the difference between the Value added (current US$) in Central Europe and Value added (current US$) in Kiribati?
Offer a very short reply. 7.92e+1. In the year 1999, what is the difference between the Value added (current US$) in Central Europe and Value added (current US$) in Pakistan?
Keep it short and to the point. 7.01e+1. In the year 1999, what is the difference between the Value added (current US$) of Chile and Value added (current US$) of Kiribati?
Your response must be concise. 1.27e+1. In the year 1999, what is the difference between the Value added (current US$) in Chile and Value added (current US$) in Pakistan?
Keep it short and to the point. 3.60e+09. In the year 1999, what is the difference between the Value added (current US$) of Kiribati and Value added (current US$) of Pakistan?
Offer a very short reply. -9.07e+09. In the year 2000, what is the difference between the Value added (current US$) in Central Europe and Value added (current US$) in Chile?
Your response must be concise. 6.57e+1. In the year 2000, what is the difference between the Value added (current US$) in Central Europe and Value added (current US$) in Kiribati?
Keep it short and to the point. 7.82e+1. In the year 2000, what is the difference between the Value added (current US$) of Central Europe and Value added (current US$) of Pakistan?
Your response must be concise. 6.81e+1. In the year 2000, what is the difference between the Value added (current US$) of Chile and Value added (current US$) of Kiribati?
Offer a terse response. 1.26e+1. In the year 2000, what is the difference between the Value added (current US$) of Chile and Value added (current US$) of Pakistan?
Offer a very short reply. 2.49e+09. In the year 2000, what is the difference between the Value added (current US$) in Kiribati and Value added (current US$) in Pakistan?
Your answer should be compact. -1.01e+1. In the year 2001, what is the difference between the Value added (current US$) of Central Europe and Value added (current US$) of Chile?
Your response must be concise. 7.27e+1. In the year 2001, what is the difference between the Value added (current US$) in Central Europe and Value added (current US$) in Kiribati?
Your response must be concise. 8.47e+1. In the year 2001, what is the difference between the Value added (current US$) of Central Europe and Value added (current US$) of Pakistan?
Provide a short and direct response. 7.43e+1. In the year 2001, what is the difference between the Value added (current US$) of Chile and Value added (current US$) of Kiribati?
Offer a very short reply. 1.20e+1. In the year 2001, what is the difference between the Value added (current US$) of Chile and Value added (current US$) of Pakistan?
Give a very brief answer. 1.57e+09. In the year 2001, what is the difference between the Value added (current US$) of Kiribati and Value added (current US$) of Pakistan?
Offer a terse response. -1.04e+1. In the year 2002, what is the difference between the Value added (current US$) of Central Europe and Value added (current US$) of Chile?
Offer a very short reply. 8.09e+1. In the year 2002, what is the difference between the Value added (current US$) in Central Europe and Value added (current US$) in Kiribati?
Provide a succinct answer. 9.27e+1. In the year 2002, what is the difference between the Value added (current US$) in Central Europe and Value added (current US$) in Pakistan?
Make the answer very short. 8.22e+1. In the year 2002, what is the difference between the Value added (current US$) in Chile and Value added (current US$) in Kiribati?
Provide a succinct answer. 1.17e+1. In the year 2002, what is the difference between the Value added (current US$) of Chile and Value added (current US$) of Pakistan?
Offer a terse response. 1.29e+09. In the year 2002, what is the difference between the Value added (current US$) of Kiribati and Value added (current US$) of Pakistan?
Offer a terse response. -1.04e+1. What is the ratio of the Value added (current US$) in Central Europe in 1995 to that in 1996?
Offer a very short reply. 0.94. What is the ratio of the Value added (current US$) in Chile in 1995 to that in 1996?
Give a very brief answer. 0.8. What is the ratio of the Value added (current US$) of Kiribati in 1995 to that in 1996?
Your answer should be very brief. 0.95. What is the ratio of the Value added (current US$) of Central Europe in 1995 to that in 1997?
Offer a very short reply. 0.94. What is the ratio of the Value added (current US$) of Chile in 1995 to that in 1997?
Provide a succinct answer. 0.73. What is the ratio of the Value added (current US$) in Kiribati in 1995 to that in 1997?
Your answer should be very brief. 0.97. What is the ratio of the Value added (current US$) of Central Europe in 1995 to that in 1998?
Your answer should be compact. 0.89. What is the ratio of the Value added (current US$) in Chile in 1995 to that in 1998?
Your response must be concise. 0.78. What is the ratio of the Value added (current US$) in Kiribati in 1995 to that in 1998?
Your response must be concise. 1.07. What is the ratio of the Value added (current US$) in Pakistan in 1995 to that in 1998?
Keep it short and to the point. 0.97. What is the ratio of the Value added (current US$) in Central Europe in 1995 to that in 1999?
Your answer should be very brief. 0.96. What is the ratio of the Value added (current US$) in Chile in 1995 to that in 1999?
Make the answer very short. 0.84. What is the ratio of the Value added (current US$) of Kiribati in 1995 to that in 1999?
Give a very brief answer. 0.96. What is the ratio of the Value added (current US$) of Pakistan in 1995 to that in 1999?
Your response must be concise. 0.98. What is the ratio of the Value added (current US$) in Central Europe in 1995 to that in 2000?
Your response must be concise. 0.97. What is the ratio of the Value added (current US$) of Chile in 1995 to that in 2000?
Make the answer very short. 0.84. What is the ratio of the Value added (current US$) of Kiribati in 1995 to that in 2000?
Your answer should be very brief. 1.13. What is the ratio of the Value added (current US$) of Pakistan in 1995 to that in 2000?
Ensure brevity in your answer.  0.88. What is the ratio of the Value added (current US$) of Central Europe in 1995 to that in 2001?
Offer a very short reply. 0.9. What is the ratio of the Value added (current US$) in Chile in 1995 to that in 2001?
Your response must be concise. 0.88. What is the ratio of the Value added (current US$) in Kiribati in 1995 to that in 2001?
Provide a short and direct response. 1.21. What is the ratio of the Value added (current US$) of Pakistan in 1995 to that in 2001?
Offer a terse response. 0.85. What is the ratio of the Value added (current US$) of Central Europe in 1995 to that in 2002?
Offer a very short reply. 0.82. What is the ratio of the Value added (current US$) in Chile in 1995 to that in 2002?
Ensure brevity in your answer.  0.9. What is the ratio of the Value added (current US$) in Kiribati in 1995 to that in 2002?
Offer a terse response. 1.18. What is the ratio of the Value added (current US$) of Pakistan in 1995 to that in 2002?
Ensure brevity in your answer.  0.85. What is the ratio of the Value added (current US$) in Central Europe in 1996 to that in 1997?
Keep it short and to the point. 1.01. What is the ratio of the Value added (current US$) in Chile in 1996 to that in 1997?
Provide a succinct answer. 0.92. What is the ratio of the Value added (current US$) of Kiribati in 1996 to that in 1997?
Give a very brief answer. 1.02. What is the ratio of the Value added (current US$) of Pakistan in 1996 to that in 1997?
Provide a succinct answer. 1.02. What is the ratio of the Value added (current US$) of Central Europe in 1996 to that in 1998?
Keep it short and to the point. 0.95. What is the ratio of the Value added (current US$) in Chile in 1996 to that in 1998?
Your answer should be very brief. 0.98. What is the ratio of the Value added (current US$) in Kiribati in 1996 to that in 1998?
Your answer should be very brief. 1.13. What is the ratio of the Value added (current US$) of Pakistan in 1996 to that in 1998?
Offer a terse response. 1.01. What is the ratio of the Value added (current US$) of Central Europe in 1996 to that in 1999?
Ensure brevity in your answer.  1.02. What is the ratio of the Value added (current US$) in Chile in 1996 to that in 1999?
Your answer should be compact. 1.05. What is the ratio of the Value added (current US$) of Kiribati in 1996 to that in 1999?
Your answer should be compact. 1.01. What is the ratio of the Value added (current US$) in Pakistan in 1996 to that in 1999?
Make the answer very short. 1.02. What is the ratio of the Value added (current US$) in Central Europe in 1996 to that in 2000?
Provide a succinct answer. 1.04. What is the ratio of the Value added (current US$) of Chile in 1996 to that in 2000?
Offer a very short reply. 1.05. What is the ratio of the Value added (current US$) in Kiribati in 1996 to that in 2000?
Your answer should be compact. 1.19. What is the ratio of the Value added (current US$) in Pakistan in 1996 to that in 2000?
Provide a succinct answer. 0.92. What is the ratio of the Value added (current US$) of Central Europe in 1996 to that in 2001?
Ensure brevity in your answer.  0.96. What is the ratio of the Value added (current US$) of Chile in 1996 to that in 2001?
Give a very brief answer. 1.1. What is the ratio of the Value added (current US$) in Kiribati in 1996 to that in 2001?
Keep it short and to the point. 1.28. What is the ratio of the Value added (current US$) in Pakistan in 1996 to that in 2001?
Provide a succinct answer. 0.89. What is the ratio of the Value added (current US$) of Central Europe in 1996 to that in 2002?
Give a very brief answer. 0.87. What is the ratio of the Value added (current US$) in Chile in 1996 to that in 2002?
Offer a terse response. 1.13. What is the ratio of the Value added (current US$) of Kiribati in 1996 to that in 2002?
Provide a short and direct response. 1.25. What is the ratio of the Value added (current US$) in Pakistan in 1996 to that in 2002?
Your answer should be compact. 0.89. What is the ratio of the Value added (current US$) in Central Europe in 1997 to that in 1998?
Provide a succinct answer. 0.95. What is the ratio of the Value added (current US$) in Chile in 1997 to that in 1998?
Your answer should be very brief. 1.07. What is the ratio of the Value added (current US$) in Kiribati in 1997 to that in 1998?
Provide a short and direct response. 1.11. What is the ratio of the Value added (current US$) in Central Europe in 1997 to that in 1999?
Your response must be concise. 1.02. What is the ratio of the Value added (current US$) in Chile in 1997 to that in 1999?
Keep it short and to the point. 1.14. What is the ratio of the Value added (current US$) of Kiribati in 1997 to that in 1999?
Your response must be concise. 0.99. What is the ratio of the Value added (current US$) of Pakistan in 1997 to that in 1999?
Your answer should be compact. 1. What is the ratio of the Value added (current US$) in Central Europe in 1997 to that in 2000?
Keep it short and to the point. 1.03. What is the ratio of the Value added (current US$) of Chile in 1997 to that in 2000?
Your answer should be compact. 1.15. What is the ratio of the Value added (current US$) in Kiribati in 1997 to that in 2000?
Give a very brief answer. 1.17. What is the ratio of the Value added (current US$) in Pakistan in 1997 to that in 2000?
Give a very brief answer. 0.9. What is the ratio of the Value added (current US$) in Central Europe in 1997 to that in 2001?
Ensure brevity in your answer.  0.95. What is the ratio of the Value added (current US$) of Chile in 1997 to that in 2001?
Provide a succinct answer. 1.2. What is the ratio of the Value added (current US$) in Kiribati in 1997 to that in 2001?
Ensure brevity in your answer.  1.25. What is the ratio of the Value added (current US$) in Pakistan in 1997 to that in 2001?
Offer a very short reply. 0.87. What is the ratio of the Value added (current US$) in Central Europe in 1997 to that in 2002?
Provide a short and direct response. 0.87. What is the ratio of the Value added (current US$) of Chile in 1997 to that in 2002?
Provide a succinct answer. 1.23. What is the ratio of the Value added (current US$) of Kiribati in 1997 to that in 2002?
Your response must be concise. 1.22. What is the ratio of the Value added (current US$) of Pakistan in 1997 to that in 2002?
Your response must be concise. 0.87. What is the ratio of the Value added (current US$) of Central Europe in 1998 to that in 1999?
Your answer should be very brief. 1.07. What is the ratio of the Value added (current US$) in Chile in 1998 to that in 1999?
Make the answer very short. 1.07. What is the ratio of the Value added (current US$) of Kiribati in 1998 to that in 1999?
Your answer should be compact. 0.89. What is the ratio of the Value added (current US$) in Central Europe in 1998 to that in 2000?
Give a very brief answer. 1.09. What is the ratio of the Value added (current US$) of Chile in 1998 to that in 2000?
Provide a short and direct response. 1.08. What is the ratio of the Value added (current US$) of Kiribati in 1998 to that in 2000?
Make the answer very short. 1.05. What is the ratio of the Value added (current US$) in Pakistan in 1998 to that in 2000?
Your answer should be very brief. 0.9. What is the ratio of the Value added (current US$) in Chile in 1998 to that in 2001?
Provide a succinct answer. 1.13. What is the ratio of the Value added (current US$) in Kiribati in 1998 to that in 2001?
Your answer should be very brief. 1.13. What is the ratio of the Value added (current US$) of Pakistan in 1998 to that in 2001?
Offer a very short reply. 0.87. What is the ratio of the Value added (current US$) of Central Europe in 1998 to that in 2002?
Ensure brevity in your answer.  0.92. What is the ratio of the Value added (current US$) of Chile in 1998 to that in 2002?
Keep it short and to the point. 1.15. What is the ratio of the Value added (current US$) of Kiribati in 1998 to that in 2002?
Your answer should be very brief. 1.1. What is the ratio of the Value added (current US$) in Pakistan in 1998 to that in 2002?
Offer a very short reply. 0.87. What is the ratio of the Value added (current US$) in Central Europe in 1999 to that in 2000?
Offer a terse response. 1.01. What is the ratio of the Value added (current US$) of Chile in 1999 to that in 2000?
Ensure brevity in your answer.  1.01. What is the ratio of the Value added (current US$) in Kiribati in 1999 to that in 2000?
Ensure brevity in your answer.  1.18. What is the ratio of the Value added (current US$) of Pakistan in 1999 to that in 2000?
Offer a very short reply. 0.9. What is the ratio of the Value added (current US$) of Central Europe in 1999 to that in 2001?
Make the answer very short. 0.93. What is the ratio of the Value added (current US$) of Chile in 1999 to that in 2001?
Your answer should be compact. 1.05. What is the ratio of the Value added (current US$) in Kiribati in 1999 to that in 2001?
Keep it short and to the point. 1.26. What is the ratio of the Value added (current US$) of Pakistan in 1999 to that in 2001?
Ensure brevity in your answer.  0.87. What is the ratio of the Value added (current US$) in Central Europe in 1999 to that in 2002?
Provide a short and direct response. 0.85. What is the ratio of the Value added (current US$) of Chile in 1999 to that in 2002?
Provide a succinct answer. 1.08. What is the ratio of the Value added (current US$) in Kiribati in 1999 to that in 2002?
Ensure brevity in your answer.  1.24. What is the ratio of the Value added (current US$) of Pakistan in 1999 to that in 2002?
Make the answer very short. 0.87. What is the ratio of the Value added (current US$) of Central Europe in 2000 to that in 2001?
Keep it short and to the point. 0.92. What is the ratio of the Value added (current US$) in Chile in 2000 to that in 2001?
Your answer should be compact. 1.05. What is the ratio of the Value added (current US$) in Kiribati in 2000 to that in 2001?
Provide a succinct answer. 1.07. What is the ratio of the Value added (current US$) of Pakistan in 2000 to that in 2001?
Give a very brief answer. 0.97. What is the ratio of the Value added (current US$) in Central Europe in 2000 to that in 2002?
Provide a short and direct response. 0.84. What is the ratio of the Value added (current US$) of Chile in 2000 to that in 2002?
Your answer should be very brief. 1.07. What is the ratio of the Value added (current US$) in Kiribati in 2000 to that in 2002?
Ensure brevity in your answer.  1.05. What is the ratio of the Value added (current US$) of Pakistan in 2000 to that in 2002?
Give a very brief answer. 0.97. What is the ratio of the Value added (current US$) in Central Europe in 2001 to that in 2002?
Offer a terse response. 0.91. What is the ratio of the Value added (current US$) of Chile in 2001 to that in 2002?
Give a very brief answer. 1.02. What is the ratio of the Value added (current US$) of Kiribati in 2001 to that in 2002?
Provide a short and direct response. 0.98. What is the difference between the highest and the second highest Value added (current US$) in Central Europe?
Keep it short and to the point. 7.56e+09. What is the difference between the highest and the second highest Value added (current US$) in Chile?
Provide a short and direct response. 8.87e+08. What is the difference between the highest and the second highest Value added (current US$) in Kiribati?
Provide a succinct answer. 3.37e+04. What is the difference between the highest and the second highest Value added (current US$) of Pakistan?
Offer a terse response. 6.15e+06. What is the difference between the highest and the lowest Value added (current US$) in Central Europe?
Offer a terse response. 1.66e+1. What is the difference between the highest and the lowest Value added (current US$) of Chile?
Make the answer very short. 3.83e+09. What is the difference between the highest and the lowest Value added (current US$) in Kiribati?
Give a very brief answer. 7.70e+05. What is the difference between the highest and the lowest Value added (current US$) in Pakistan?
Your answer should be very brief. 1.58e+09. 